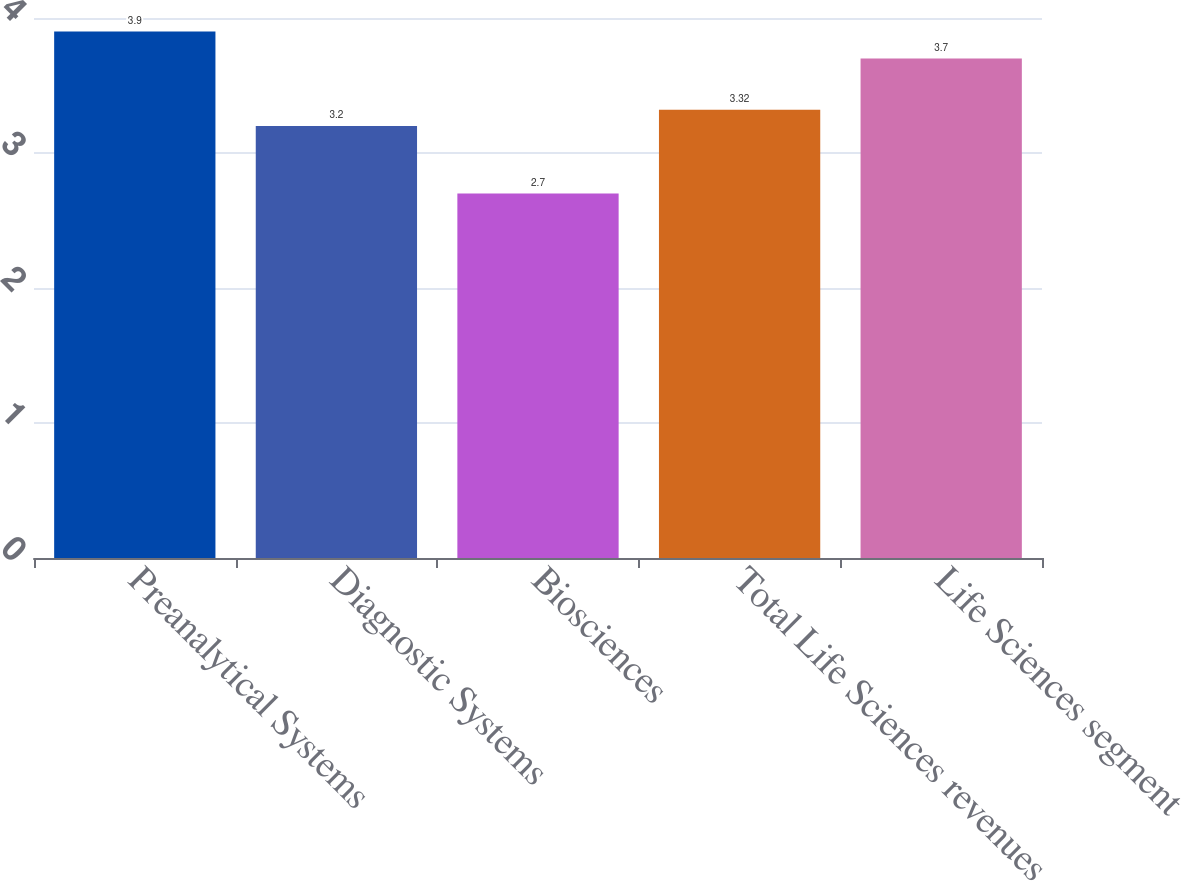Convert chart. <chart><loc_0><loc_0><loc_500><loc_500><bar_chart><fcel>Preanalytical Systems<fcel>Diagnostic Systems<fcel>Biosciences<fcel>Total Life Sciences revenues<fcel>Life Sciences segment<nl><fcel>3.9<fcel>3.2<fcel>2.7<fcel>3.32<fcel>3.7<nl></chart> 